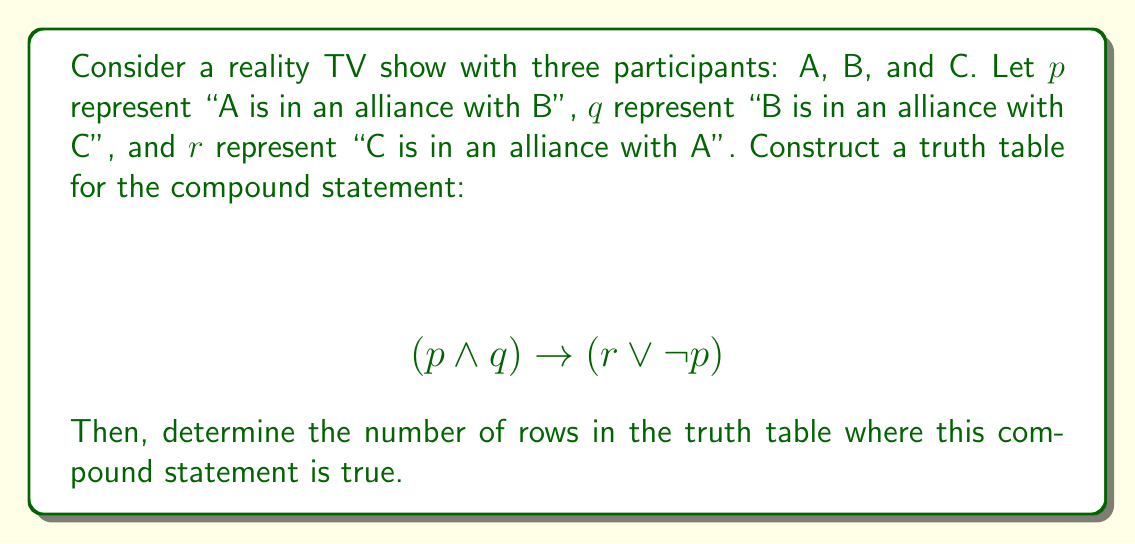Can you answer this question? To solve this problem, we need to follow these steps:

1. Identify the atomic propositions: p, q, and r
2. Construct the truth table with all possible combinations of truth values for p, q, and r
3. Evaluate the compound statement for each row
4. Count the number of rows where the statement is true

Let's construct the truth table:

$$\begin{array}{|c|c|c|c|c|c|c|}
\hline
p & q & r & p \land q & r \lor \neg p & (p \land q) \rightarrow (r \lor \neg p) \\
\hline
T & T & T & T & T & T \\
T & T & F & T & F & F \\
T & F & T & F & T & T \\
T & F & F & F & F & T \\
F & T & T & F & T & T \\
F & T & F & F & T & T \\
F & F & T & F & T & T \\
F & F & F & F & T & T \\
\hline
\end{array}$$

Explanation of each column:
- Columns 1-3: All possible combinations of truth values for p, q, and r
- Column 4: $p \land q$ (true only when both p and q are true)
- Column 5: $r \lor \neg p$ (true when either r is true or p is false)
- Column 6: $(p \land q) \rightarrow (r \lor \neg p)$ (false only when the antecedent is true and the consequent is false)

Now, we count the number of rows where the final column is true. There are 7 such rows.
Answer: The compound statement $(p \land q) \rightarrow (r \lor \neg p)$ is true in 7 rows of the truth table. 